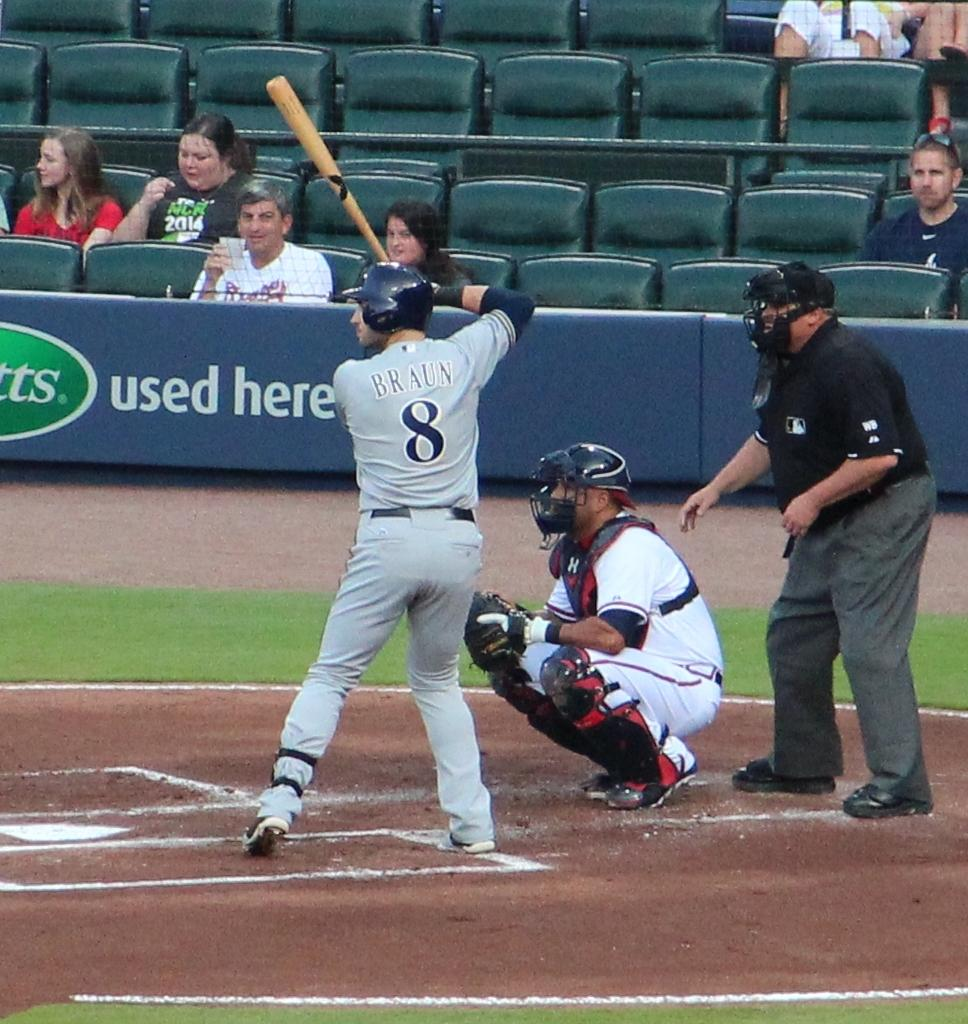<image>
Render a clear and concise summary of the photo. A baseball player has "BRAUN 8" on the back of his shirt. 